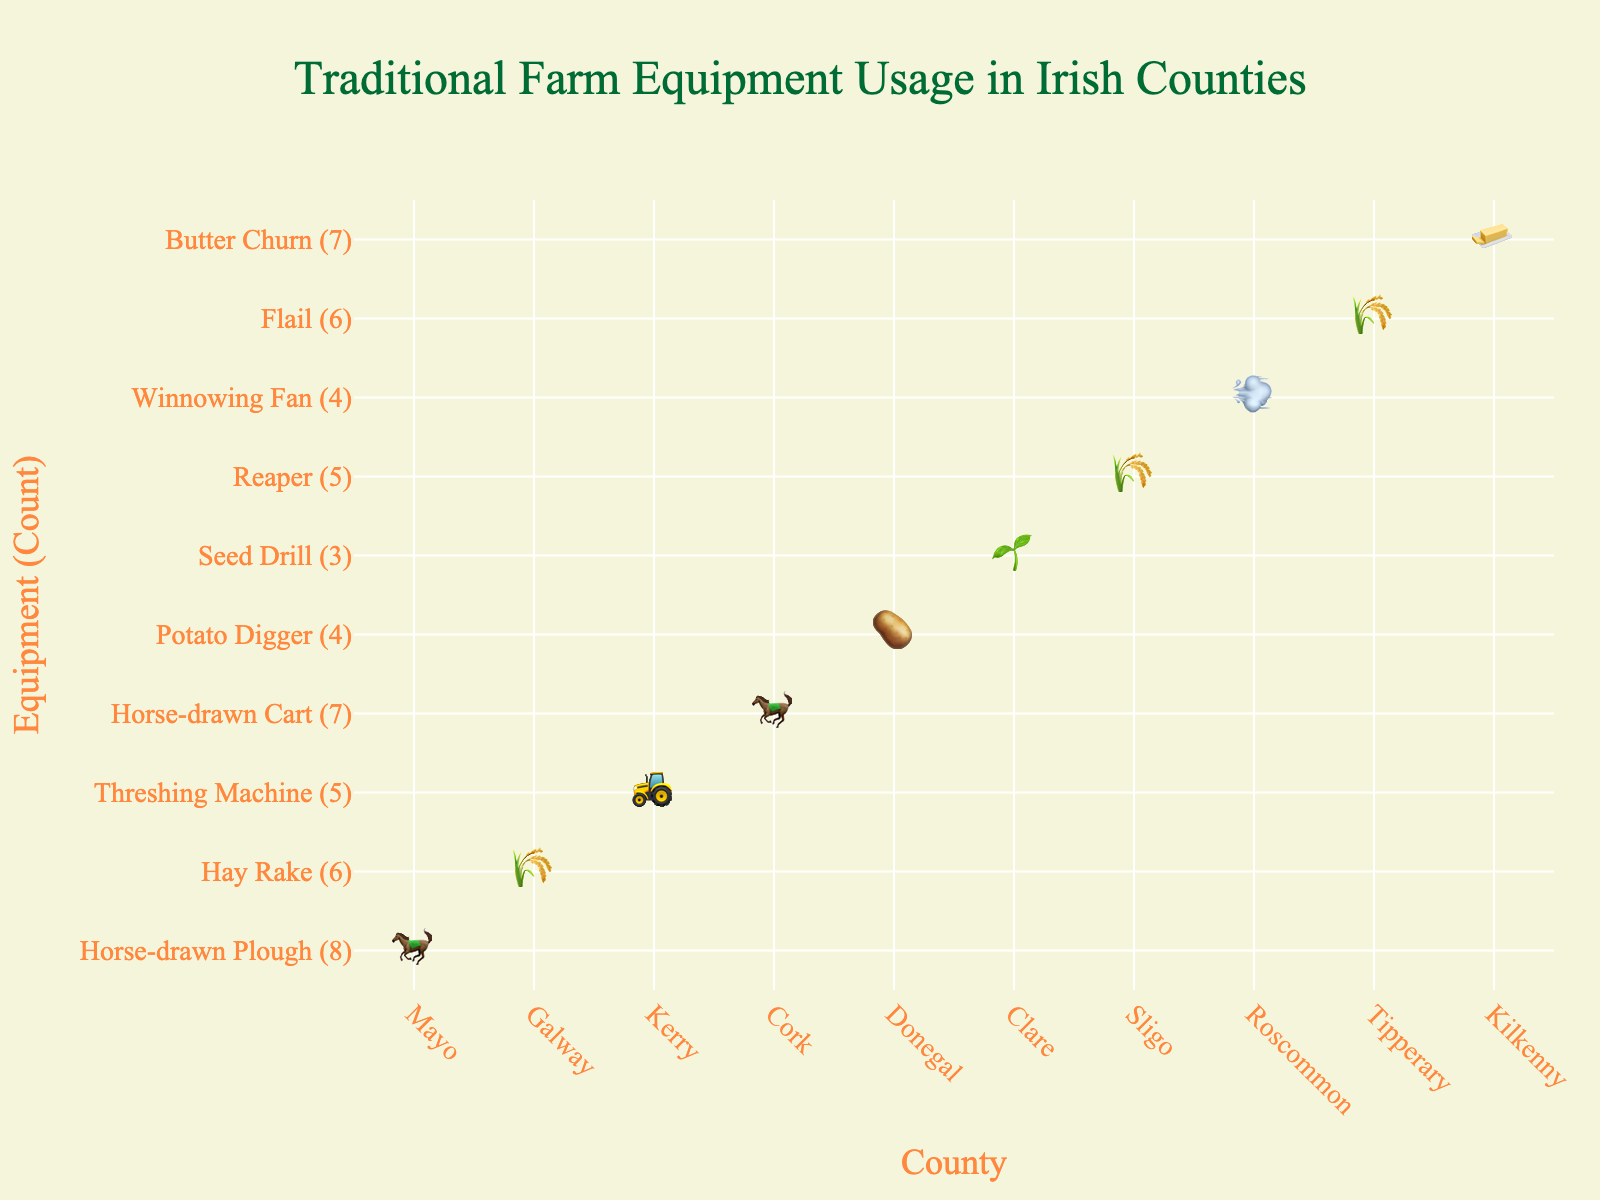what's the title of the figure? The title is typically placed at the top of the figure. By looking at the figure's top, we see the title prominently displayed.
Answer: Traditional Farm Equipment Usage in Irish Counties Which county used the Hay Rake the most? Locate the equipment labeled "Hay Rake" and check the corresponding county and its count. Galway is associated with the Hay Rake (6).
Answer: Galway How many counties used the Horse-drawn Plough? Scan for the symbol representing the Horse-drawn Plough and count the counties listed with this equipment. The Horse-drawn Plough was used in Mayo (8).
Answer: 1 Which equipment had an equal count of 4? Identify from the y-axis the equipment which had counts of 4. The Potato Digger, and Winnowing Fan each had 4.
Answer: Potato Digger, Winnowing Fan What is the total count of equipment used in Kilkenny and Donegal combined? Locate and sum the counts for both Kilkenny and Donegal. Kilkenny (Butter Churn) has 7 and Donegal (Potato Digger) has 4. 7 + 4 = 11
Answer: 11 Which county has the highest usage count for any single piece of equipment? Examine each category for each county and identify the highest number. Mayo has the highest usage count with 8 for the Horse-drawn Plough.
Answer: Mayo How many types of equipment were used in total across all counties? Count the unique equipment names on the y-axis or legend. There are 10 different types of equipment listed.
Answer: 10 Which equipment was used more, the Reaper or the Flail? Compare the counts for the Reaper (5) and the Flail (6). The Flail has a higher count.
Answer: Flail Which county has exactly 7 equipment usages? Check the counties for any that shows a count of 7 for an equipment. Cork (Horse-drawn Cart) and Kilkenny (Butter Churn) both have counts of 7.
Answer: Cork, Kilkenny What's the difference in the count of Hay Rake and Seed Drill? Subtract the count of the Seed Drill (3) from the count of the Hay Rake (6). 6 - 3 = 3
Answer: 3 